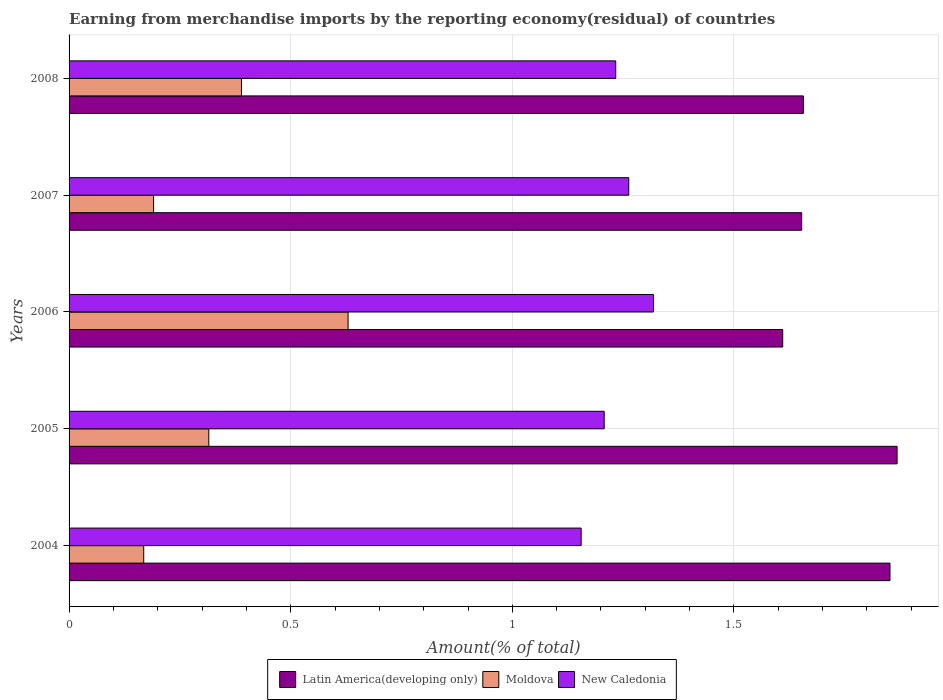How many different coloured bars are there?
Make the answer very short. 3. Are the number of bars on each tick of the Y-axis equal?
Make the answer very short. Yes. How many bars are there on the 5th tick from the top?
Provide a succinct answer. 3. How many bars are there on the 2nd tick from the bottom?
Your answer should be compact. 3. What is the percentage of amount earned from merchandise imports in New Caledonia in 2007?
Your response must be concise. 1.26. Across all years, what is the maximum percentage of amount earned from merchandise imports in Moldova?
Your response must be concise. 0.63. Across all years, what is the minimum percentage of amount earned from merchandise imports in Latin America(developing only)?
Keep it short and to the point. 1.61. In which year was the percentage of amount earned from merchandise imports in New Caledonia maximum?
Provide a short and direct response. 2006. What is the total percentage of amount earned from merchandise imports in Moldova in the graph?
Offer a very short reply. 1.69. What is the difference between the percentage of amount earned from merchandise imports in Latin America(developing only) in 2006 and that in 2007?
Keep it short and to the point. -0.04. What is the difference between the percentage of amount earned from merchandise imports in Moldova in 2008 and the percentage of amount earned from merchandise imports in New Caledonia in 2007?
Offer a very short reply. -0.87. What is the average percentage of amount earned from merchandise imports in New Caledonia per year?
Offer a terse response. 1.24. In the year 2008, what is the difference between the percentage of amount earned from merchandise imports in Latin America(developing only) and percentage of amount earned from merchandise imports in Moldova?
Make the answer very short. 1.27. What is the ratio of the percentage of amount earned from merchandise imports in New Caledonia in 2007 to that in 2008?
Provide a succinct answer. 1.02. Is the difference between the percentage of amount earned from merchandise imports in Latin America(developing only) in 2007 and 2008 greater than the difference between the percentage of amount earned from merchandise imports in Moldova in 2007 and 2008?
Offer a very short reply. Yes. What is the difference between the highest and the second highest percentage of amount earned from merchandise imports in Latin America(developing only)?
Offer a very short reply. 0.02. What is the difference between the highest and the lowest percentage of amount earned from merchandise imports in Latin America(developing only)?
Your answer should be very brief. 0.26. Is the sum of the percentage of amount earned from merchandise imports in New Caledonia in 2005 and 2008 greater than the maximum percentage of amount earned from merchandise imports in Moldova across all years?
Keep it short and to the point. Yes. What does the 3rd bar from the top in 2008 represents?
Make the answer very short. Latin America(developing only). What does the 1st bar from the bottom in 2008 represents?
Give a very brief answer. Latin America(developing only). How many bars are there?
Your response must be concise. 15. Are all the bars in the graph horizontal?
Ensure brevity in your answer.  Yes. Does the graph contain any zero values?
Offer a very short reply. No. Does the graph contain grids?
Your answer should be very brief. Yes. How many legend labels are there?
Give a very brief answer. 3. What is the title of the graph?
Offer a terse response. Earning from merchandise imports by the reporting economy(residual) of countries. Does "South Africa" appear as one of the legend labels in the graph?
Your answer should be compact. No. What is the label or title of the X-axis?
Ensure brevity in your answer.  Amount(% of total). What is the label or title of the Y-axis?
Your response must be concise. Years. What is the Amount(% of total) in Latin America(developing only) in 2004?
Ensure brevity in your answer.  1.85. What is the Amount(% of total) of Moldova in 2004?
Offer a very short reply. 0.17. What is the Amount(% of total) in New Caledonia in 2004?
Your response must be concise. 1.16. What is the Amount(% of total) in Latin America(developing only) in 2005?
Your answer should be very brief. 1.87. What is the Amount(% of total) of Moldova in 2005?
Give a very brief answer. 0.32. What is the Amount(% of total) in New Caledonia in 2005?
Your response must be concise. 1.21. What is the Amount(% of total) in Latin America(developing only) in 2006?
Make the answer very short. 1.61. What is the Amount(% of total) in Moldova in 2006?
Your answer should be compact. 0.63. What is the Amount(% of total) of New Caledonia in 2006?
Offer a terse response. 1.32. What is the Amount(% of total) of Latin America(developing only) in 2007?
Offer a terse response. 1.65. What is the Amount(% of total) of Moldova in 2007?
Provide a short and direct response. 0.19. What is the Amount(% of total) in New Caledonia in 2007?
Offer a very short reply. 1.26. What is the Amount(% of total) in Latin America(developing only) in 2008?
Make the answer very short. 1.66. What is the Amount(% of total) in Moldova in 2008?
Your answer should be compact. 0.39. What is the Amount(% of total) of New Caledonia in 2008?
Make the answer very short. 1.23. Across all years, what is the maximum Amount(% of total) of Latin America(developing only)?
Provide a short and direct response. 1.87. Across all years, what is the maximum Amount(% of total) of Moldova?
Your answer should be compact. 0.63. Across all years, what is the maximum Amount(% of total) of New Caledonia?
Give a very brief answer. 1.32. Across all years, what is the minimum Amount(% of total) of Latin America(developing only)?
Your answer should be very brief. 1.61. Across all years, what is the minimum Amount(% of total) of Moldova?
Provide a succinct answer. 0.17. Across all years, what is the minimum Amount(% of total) in New Caledonia?
Keep it short and to the point. 1.16. What is the total Amount(% of total) in Latin America(developing only) in the graph?
Give a very brief answer. 8.64. What is the total Amount(% of total) of Moldova in the graph?
Your answer should be very brief. 1.69. What is the total Amount(% of total) of New Caledonia in the graph?
Give a very brief answer. 6.18. What is the difference between the Amount(% of total) of Latin America(developing only) in 2004 and that in 2005?
Provide a short and direct response. -0.02. What is the difference between the Amount(% of total) in Moldova in 2004 and that in 2005?
Your response must be concise. -0.15. What is the difference between the Amount(% of total) of New Caledonia in 2004 and that in 2005?
Provide a succinct answer. -0.05. What is the difference between the Amount(% of total) in Latin America(developing only) in 2004 and that in 2006?
Keep it short and to the point. 0.24. What is the difference between the Amount(% of total) of Moldova in 2004 and that in 2006?
Provide a short and direct response. -0.46. What is the difference between the Amount(% of total) in New Caledonia in 2004 and that in 2006?
Give a very brief answer. -0.16. What is the difference between the Amount(% of total) of Latin America(developing only) in 2004 and that in 2007?
Make the answer very short. 0.2. What is the difference between the Amount(% of total) in Moldova in 2004 and that in 2007?
Your response must be concise. -0.02. What is the difference between the Amount(% of total) in New Caledonia in 2004 and that in 2007?
Your answer should be very brief. -0.11. What is the difference between the Amount(% of total) of Latin America(developing only) in 2004 and that in 2008?
Your answer should be compact. 0.2. What is the difference between the Amount(% of total) of Moldova in 2004 and that in 2008?
Provide a succinct answer. -0.22. What is the difference between the Amount(% of total) of New Caledonia in 2004 and that in 2008?
Give a very brief answer. -0.08. What is the difference between the Amount(% of total) in Latin America(developing only) in 2005 and that in 2006?
Offer a very short reply. 0.26. What is the difference between the Amount(% of total) of Moldova in 2005 and that in 2006?
Offer a very short reply. -0.31. What is the difference between the Amount(% of total) of New Caledonia in 2005 and that in 2006?
Your answer should be very brief. -0.11. What is the difference between the Amount(% of total) of Latin America(developing only) in 2005 and that in 2007?
Give a very brief answer. 0.22. What is the difference between the Amount(% of total) of Moldova in 2005 and that in 2007?
Your answer should be compact. 0.12. What is the difference between the Amount(% of total) of New Caledonia in 2005 and that in 2007?
Give a very brief answer. -0.06. What is the difference between the Amount(% of total) of Latin America(developing only) in 2005 and that in 2008?
Provide a short and direct response. 0.21. What is the difference between the Amount(% of total) of Moldova in 2005 and that in 2008?
Give a very brief answer. -0.07. What is the difference between the Amount(% of total) of New Caledonia in 2005 and that in 2008?
Keep it short and to the point. -0.03. What is the difference between the Amount(% of total) in Latin America(developing only) in 2006 and that in 2007?
Keep it short and to the point. -0.04. What is the difference between the Amount(% of total) of Moldova in 2006 and that in 2007?
Provide a short and direct response. 0.44. What is the difference between the Amount(% of total) in New Caledonia in 2006 and that in 2007?
Provide a succinct answer. 0.06. What is the difference between the Amount(% of total) of Latin America(developing only) in 2006 and that in 2008?
Provide a succinct answer. -0.05. What is the difference between the Amount(% of total) of Moldova in 2006 and that in 2008?
Ensure brevity in your answer.  0.24. What is the difference between the Amount(% of total) of New Caledonia in 2006 and that in 2008?
Your answer should be very brief. 0.09. What is the difference between the Amount(% of total) in Latin America(developing only) in 2007 and that in 2008?
Make the answer very short. -0. What is the difference between the Amount(% of total) in Moldova in 2007 and that in 2008?
Offer a very short reply. -0.2. What is the difference between the Amount(% of total) in New Caledonia in 2007 and that in 2008?
Offer a terse response. 0.03. What is the difference between the Amount(% of total) in Latin America(developing only) in 2004 and the Amount(% of total) in Moldova in 2005?
Ensure brevity in your answer.  1.54. What is the difference between the Amount(% of total) in Latin America(developing only) in 2004 and the Amount(% of total) in New Caledonia in 2005?
Make the answer very short. 0.64. What is the difference between the Amount(% of total) in Moldova in 2004 and the Amount(% of total) in New Caledonia in 2005?
Offer a terse response. -1.04. What is the difference between the Amount(% of total) in Latin America(developing only) in 2004 and the Amount(% of total) in Moldova in 2006?
Offer a very short reply. 1.22. What is the difference between the Amount(% of total) in Latin America(developing only) in 2004 and the Amount(% of total) in New Caledonia in 2006?
Give a very brief answer. 0.53. What is the difference between the Amount(% of total) of Moldova in 2004 and the Amount(% of total) of New Caledonia in 2006?
Ensure brevity in your answer.  -1.15. What is the difference between the Amount(% of total) in Latin America(developing only) in 2004 and the Amount(% of total) in Moldova in 2007?
Give a very brief answer. 1.66. What is the difference between the Amount(% of total) in Latin America(developing only) in 2004 and the Amount(% of total) in New Caledonia in 2007?
Make the answer very short. 0.59. What is the difference between the Amount(% of total) in Moldova in 2004 and the Amount(% of total) in New Caledonia in 2007?
Your answer should be very brief. -1.09. What is the difference between the Amount(% of total) of Latin America(developing only) in 2004 and the Amount(% of total) of Moldova in 2008?
Your response must be concise. 1.46. What is the difference between the Amount(% of total) in Latin America(developing only) in 2004 and the Amount(% of total) in New Caledonia in 2008?
Ensure brevity in your answer.  0.62. What is the difference between the Amount(% of total) of Moldova in 2004 and the Amount(% of total) of New Caledonia in 2008?
Your answer should be very brief. -1.06. What is the difference between the Amount(% of total) of Latin America(developing only) in 2005 and the Amount(% of total) of Moldova in 2006?
Offer a terse response. 1.24. What is the difference between the Amount(% of total) of Latin America(developing only) in 2005 and the Amount(% of total) of New Caledonia in 2006?
Ensure brevity in your answer.  0.55. What is the difference between the Amount(% of total) of Moldova in 2005 and the Amount(% of total) of New Caledonia in 2006?
Ensure brevity in your answer.  -1. What is the difference between the Amount(% of total) in Latin America(developing only) in 2005 and the Amount(% of total) in Moldova in 2007?
Ensure brevity in your answer.  1.68. What is the difference between the Amount(% of total) in Latin America(developing only) in 2005 and the Amount(% of total) in New Caledonia in 2007?
Provide a succinct answer. 0.61. What is the difference between the Amount(% of total) of Moldova in 2005 and the Amount(% of total) of New Caledonia in 2007?
Offer a very short reply. -0.95. What is the difference between the Amount(% of total) of Latin America(developing only) in 2005 and the Amount(% of total) of Moldova in 2008?
Your answer should be very brief. 1.48. What is the difference between the Amount(% of total) of Latin America(developing only) in 2005 and the Amount(% of total) of New Caledonia in 2008?
Give a very brief answer. 0.63. What is the difference between the Amount(% of total) in Moldova in 2005 and the Amount(% of total) in New Caledonia in 2008?
Make the answer very short. -0.92. What is the difference between the Amount(% of total) of Latin America(developing only) in 2006 and the Amount(% of total) of Moldova in 2007?
Provide a short and direct response. 1.42. What is the difference between the Amount(% of total) in Latin America(developing only) in 2006 and the Amount(% of total) in New Caledonia in 2007?
Your response must be concise. 0.35. What is the difference between the Amount(% of total) in Moldova in 2006 and the Amount(% of total) in New Caledonia in 2007?
Ensure brevity in your answer.  -0.63. What is the difference between the Amount(% of total) of Latin America(developing only) in 2006 and the Amount(% of total) of Moldova in 2008?
Your answer should be compact. 1.22. What is the difference between the Amount(% of total) in Latin America(developing only) in 2006 and the Amount(% of total) in New Caledonia in 2008?
Ensure brevity in your answer.  0.38. What is the difference between the Amount(% of total) in Moldova in 2006 and the Amount(% of total) in New Caledonia in 2008?
Your answer should be very brief. -0.6. What is the difference between the Amount(% of total) of Latin America(developing only) in 2007 and the Amount(% of total) of Moldova in 2008?
Make the answer very short. 1.26. What is the difference between the Amount(% of total) in Latin America(developing only) in 2007 and the Amount(% of total) in New Caledonia in 2008?
Ensure brevity in your answer.  0.42. What is the difference between the Amount(% of total) of Moldova in 2007 and the Amount(% of total) of New Caledonia in 2008?
Your answer should be compact. -1.04. What is the average Amount(% of total) in Latin America(developing only) per year?
Offer a terse response. 1.73. What is the average Amount(% of total) of Moldova per year?
Provide a short and direct response. 0.34. What is the average Amount(% of total) in New Caledonia per year?
Make the answer very short. 1.24. In the year 2004, what is the difference between the Amount(% of total) in Latin America(developing only) and Amount(% of total) in Moldova?
Offer a very short reply. 1.68. In the year 2004, what is the difference between the Amount(% of total) in Latin America(developing only) and Amount(% of total) in New Caledonia?
Offer a very short reply. 0.7. In the year 2004, what is the difference between the Amount(% of total) of Moldova and Amount(% of total) of New Caledonia?
Give a very brief answer. -0.99. In the year 2005, what is the difference between the Amount(% of total) in Latin America(developing only) and Amount(% of total) in Moldova?
Ensure brevity in your answer.  1.55. In the year 2005, what is the difference between the Amount(% of total) of Latin America(developing only) and Amount(% of total) of New Caledonia?
Provide a short and direct response. 0.66. In the year 2005, what is the difference between the Amount(% of total) in Moldova and Amount(% of total) in New Caledonia?
Keep it short and to the point. -0.89. In the year 2006, what is the difference between the Amount(% of total) of Latin America(developing only) and Amount(% of total) of Moldova?
Provide a succinct answer. 0.98. In the year 2006, what is the difference between the Amount(% of total) of Latin America(developing only) and Amount(% of total) of New Caledonia?
Make the answer very short. 0.29. In the year 2006, what is the difference between the Amount(% of total) in Moldova and Amount(% of total) in New Caledonia?
Your answer should be very brief. -0.69. In the year 2007, what is the difference between the Amount(% of total) of Latin America(developing only) and Amount(% of total) of Moldova?
Offer a terse response. 1.46. In the year 2007, what is the difference between the Amount(% of total) of Latin America(developing only) and Amount(% of total) of New Caledonia?
Ensure brevity in your answer.  0.39. In the year 2007, what is the difference between the Amount(% of total) of Moldova and Amount(% of total) of New Caledonia?
Your answer should be very brief. -1.07. In the year 2008, what is the difference between the Amount(% of total) in Latin America(developing only) and Amount(% of total) in Moldova?
Offer a very short reply. 1.27. In the year 2008, what is the difference between the Amount(% of total) in Latin America(developing only) and Amount(% of total) in New Caledonia?
Your response must be concise. 0.42. In the year 2008, what is the difference between the Amount(% of total) in Moldova and Amount(% of total) in New Caledonia?
Ensure brevity in your answer.  -0.84. What is the ratio of the Amount(% of total) in Latin America(developing only) in 2004 to that in 2005?
Offer a very short reply. 0.99. What is the ratio of the Amount(% of total) of Moldova in 2004 to that in 2005?
Provide a short and direct response. 0.53. What is the ratio of the Amount(% of total) in New Caledonia in 2004 to that in 2005?
Your response must be concise. 0.96. What is the ratio of the Amount(% of total) of Latin America(developing only) in 2004 to that in 2006?
Provide a succinct answer. 1.15. What is the ratio of the Amount(% of total) of Moldova in 2004 to that in 2006?
Offer a very short reply. 0.27. What is the ratio of the Amount(% of total) of New Caledonia in 2004 to that in 2006?
Ensure brevity in your answer.  0.88. What is the ratio of the Amount(% of total) of Latin America(developing only) in 2004 to that in 2007?
Keep it short and to the point. 1.12. What is the ratio of the Amount(% of total) in Moldova in 2004 to that in 2007?
Make the answer very short. 0.88. What is the ratio of the Amount(% of total) of New Caledonia in 2004 to that in 2007?
Keep it short and to the point. 0.92. What is the ratio of the Amount(% of total) in Latin America(developing only) in 2004 to that in 2008?
Keep it short and to the point. 1.12. What is the ratio of the Amount(% of total) of Moldova in 2004 to that in 2008?
Offer a very short reply. 0.43. What is the ratio of the Amount(% of total) in New Caledonia in 2004 to that in 2008?
Your response must be concise. 0.94. What is the ratio of the Amount(% of total) in Latin America(developing only) in 2005 to that in 2006?
Offer a very short reply. 1.16. What is the ratio of the Amount(% of total) in Moldova in 2005 to that in 2006?
Your answer should be very brief. 0.5. What is the ratio of the Amount(% of total) of New Caledonia in 2005 to that in 2006?
Your answer should be very brief. 0.92. What is the ratio of the Amount(% of total) in Latin America(developing only) in 2005 to that in 2007?
Offer a terse response. 1.13. What is the ratio of the Amount(% of total) in Moldova in 2005 to that in 2007?
Offer a very short reply. 1.65. What is the ratio of the Amount(% of total) in New Caledonia in 2005 to that in 2007?
Your answer should be very brief. 0.96. What is the ratio of the Amount(% of total) in Latin America(developing only) in 2005 to that in 2008?
Keep it short and to the point. 1.13. What is the ratio of the Amount(% of total) in Moldova in 2005 to that in 2008?
Provide a succinct answer. 0.81. What is the ratio of the Amount(% of total) of New Caledonia in 2005 to that in 2008?
Offer a very short reply. 0.98. What is the ratio of the Amount(% of total) of Latin America(developing only) in 2006 to that in 2007?
Provide a short and direct response. 0.97. What is the ratio of the Amount(% of total) in Moldova in 2006 to that in 2007?
Your response must be concise. 3.3. What is the ratio of the Amount(% of total) of New Caledonia in 2006 to that in 2007?
Provide a short and direct response. 1.04. What is the ratio of the Amount(% of total) of Latin America(developing only) in 2006 to that in 2008?
Keep it short and to the point. 0.97. What is the ratio of the Amount(% of total) of Moldova in 2006 to that in 2008?
Keep it short and to the point. 1.62. What is the ratio of the Amount(% of total) of New Caledonia in 2006 to that in 2008?
Give a very brief answer. 1.07. What is the ratio of the Amount(% of total) of Latin America(developing only) in 2007 to that in 2008?
Your response must be concise. 1. What is the ratio of the Amount(% of total) of Moldova in 2007 to that in 2008?
Make the answer very short. 0.49. What is the ratio of the Amount(% of total) in New Caledonia in 2007 to that in 2008?
Ensure brevity in your answer.  1.02. What is the difference between the highest and the second highest Amount(% of total) in Latin America(developing only)?
Ensure brevity in your answer.  0.02. What is the difference between the highest and the second highest Amount(% of total) of Moldova?
Your answer should be very brief. 0.24. What is the difference between the highest and the second highest Amount(% of total) in New Caledonia?
Your answer should be very brief. 0.06. What is the difference between the highest and the lowest Amount(% of total) in Latin America(developing only)?
Keep it short and to the point. 0.26. What is the difference between the highest and the lowest Amount(% of total) of Moldova?
Provide a succinct answer. 0.46. What is the difference between the highest and the lowest Amount(% of total) in New Caledonia?
Give a very brief answer. 0.16. 